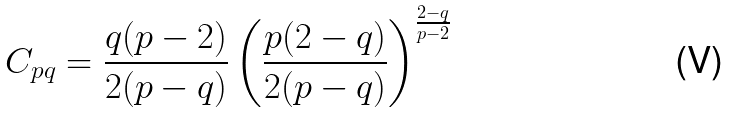<formula> <loc_0><loc_0><loc_500><loc_500>C _ { p q } = \frac { q ( p - 2 ) } { 2 ( p - q ) } \left ( \frac { p ( 2 - q ) } { 2 ( p - q ) } \right ) ^ { \frac { 2 - q } { p - 2 } }</formula> 